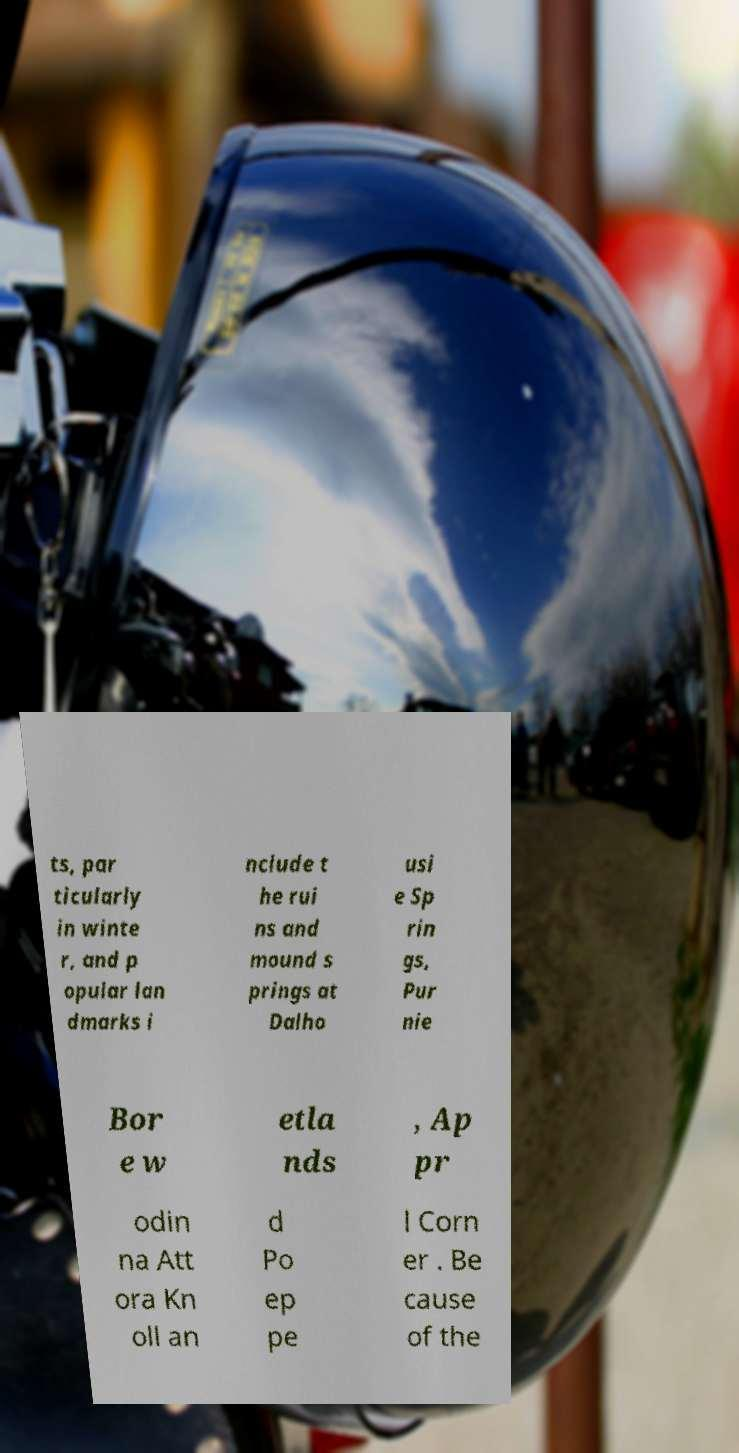For documentation purposes, I need the text within this image transcribed. Could you provide that? ts, par ticularly in winte r, and p opular lan dmarks i nclude t he rui ns and mound s prings at Dalho usi e Sp rin gs, Pur nie Bor e w etla nds , Ap pr odin na Att ora Kn oll an d Po ep pe l Corn er . Be cause of the 